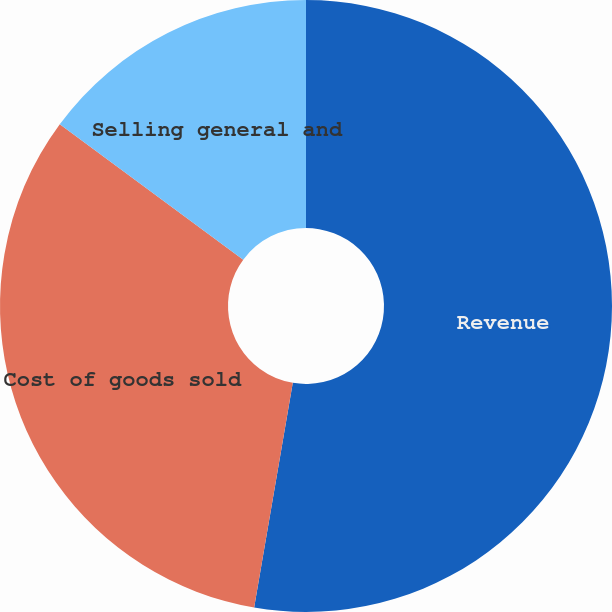<chart> <loc_0><loc_0><loc_500><loc_500><pie_chart><fcel>Revenue<fcel>Cost of goods sold<fcel>Selling general and<nl><fcel>52.71%<fcel>32.41%<fcel>14.88%<nl></chart> 